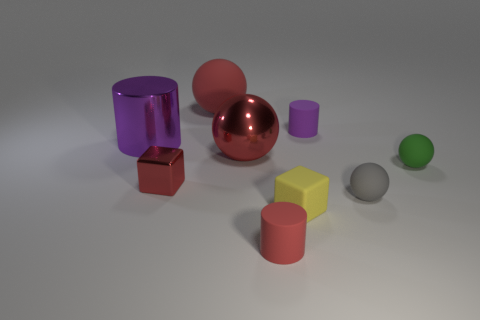Add 1 red rubber objects. How many objects exist? 10 Subtract all balls. How many objects are left? 5 Add 9 small red blocks. How many small red blocks exist? 10 Subtract 0 green blocks. How many objects are left? 9 Subtract all big rubber balls. Subtract all tiny red metallic objects. How many objects are left? 7 Add 6 big purple cylinders. How many big purple cylinders are left? 7 